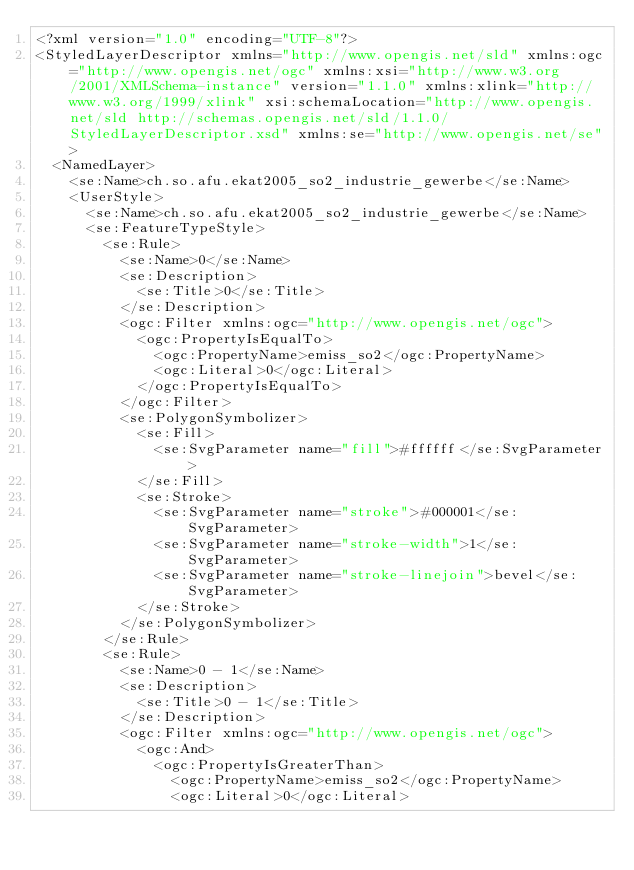Convert code to text. <code><loc_0><loc_0><loc_500><loc_500><_Scheme_><?xml version="1.0" encoding="UTF-8"?>
<StyledLayerDescriptor xmlns="http://www.opengis.net/sld" xmlns:ogc="http://www.opengis.net/ogc" xmlns:xsi="http://www.w3.org/2001/XMLSchema-instance" version="1.1.0" xmlns:xlink="http://www.w3.org/1999/xlink" xsi:schemaLocation="http://www.opengis.net/sld http://schemas.opengis.net/sld/1.1.0/StyledLayerDescriptor.xsd" xmlns:se="http://www.opengis.net/se">
  <NamedLayer>
    <se:Name>ch.so.afu.ekat2005_so2_industrie_gewerbe</se:Name>
    <UserStyle>
      <se:Name>ch.so.afu.ekat2005_so2_industrie_gewerbe</se:Name>
      <se:FeatureTypeStyle>
        <se:Rule>
          <se:Name>0</se:Name>
          <se:Description>
            <se:Title>0</se:Title>
          </se:Description>
          <ogc:Filter xmlns:ogc="http://www.opengis.net/ogc">
            <ogc:PropertyIsEqualTo>
              <ogc:PropertyName>emiss_so2</ogc:PropertyName>
              <ogc:Literal>0</ogc:Literal>
            </ogc:PropertyIsEqualTo>
          </ogc:Filter>
          <se:PolygonSymbolizer>
            <se:Fill>
              <se:SvgParameter name="fill">#ffffff</se:SvgParameter>
            </se:Fill>
            <se:Stroke>
              <se:SvgParameter name="stroke">#000001</se:SvgParameter>
              <se:SvgParameter name="stroke-width">1</se:SvgParameter>
              <se:SvgParameter name="stroke-linejoin">bevel</se:SvgParameter>
            </se:Stroke>
          </se:PolygonSymbolizer>
        </se:Rule>
        <se:Rule>
          <se:Name>0 - 1</se:Name>
          <se:Description>
            <se:Title>0 - 1</se:Title>
          </se:Description>
          <ogc:Filter xmlns:ogc="http://www.opengis.net/ogc">
            <ogc:And>
              <ogc:PropertyIsGreaterThan>
                <ogc:PropertyName>emiss_so2</ogc:PropertyName>
                <ogc:Literal>0</ogc:Literal></code> 